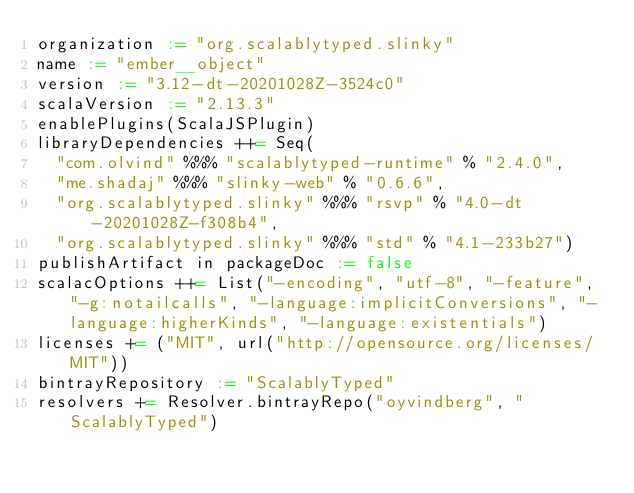Convert code to text. <code><loc_0><loc_0><loc_500><loc_500><_Scala_>organization := "org.scalablytyped.slinky"
name := "ember__object"
version := "3.12-dt-20201028Z-3524c0"
scalaVersion := "2.13.3"
enablePlugins(ScalaJSPlugin)
libraryDependencies ++= Seq(
  "com.olvind" %%% "scalablytyped-runtime" % "2.4.0",
  "me.shadaj" %%% "slinky-web" % "0.6.6",
  "org.scalablytyped.slinky" %%% "rsvp" % "4.0-dt-20201028Z-f308b4",
  "org.scalablytyped.slinky" %%% "std" % "4.1-233b27")
publishArtifact in packageDoc := false
scalacOptions ++= List("-encoding", "utf-8", "-feature", "-g:notailcalls", "-language:implicitConversions", "-language:higherKinds", "-language:existentials")
licenses += ("MIT", url("http://opensource.org/licenses/MIT"))
bintrayRepository := "ScalablyTyped"
resolvers += Resolver.bintrayRepo("oyvindberg", "ScalablyTyped")
</code> 